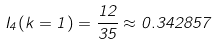<formula> <loc_0><loc_0><loc_500><loc_500>I _ { 4 } ( k = 1 ) = \frac { 1 2 } { 3 5 } \approx 0 . 3 4 2 8 5 7</formula> 